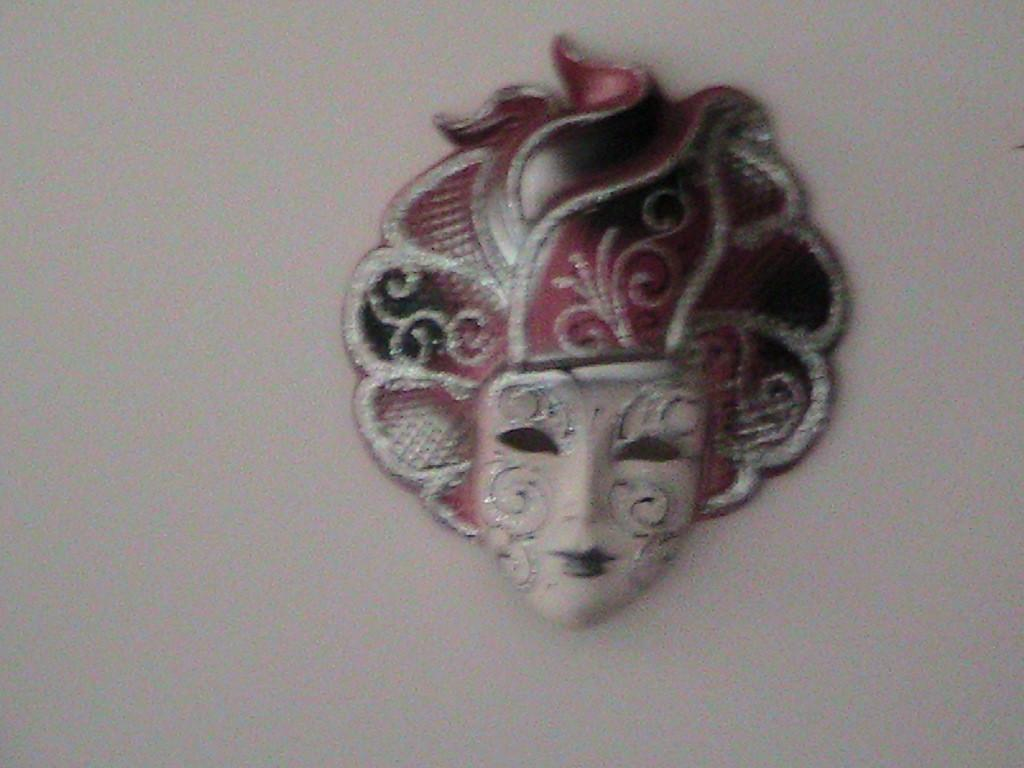What is the main subject of the image? The main subject of the image is a human face sculpture. Where is the sculpture located in the image? The sculpture is attached to a wall. What type of soup is being served in the image? There is no soup present in the image; it features a human face sculpture attached to a wall. How many ants can be seen crawling on the sculpture in the image? There are no ants present in the image; it features a human face sculpture attached to a wall. 